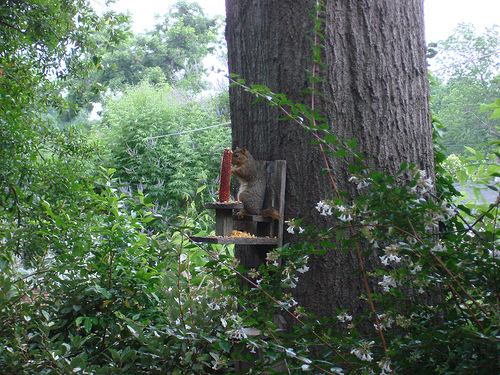<image>
Is there a squirrel on the tree? No. The squirrel is not positioned on the tree. They may be near each other, but the squirrel is not supported by or resting on top of the tree. 